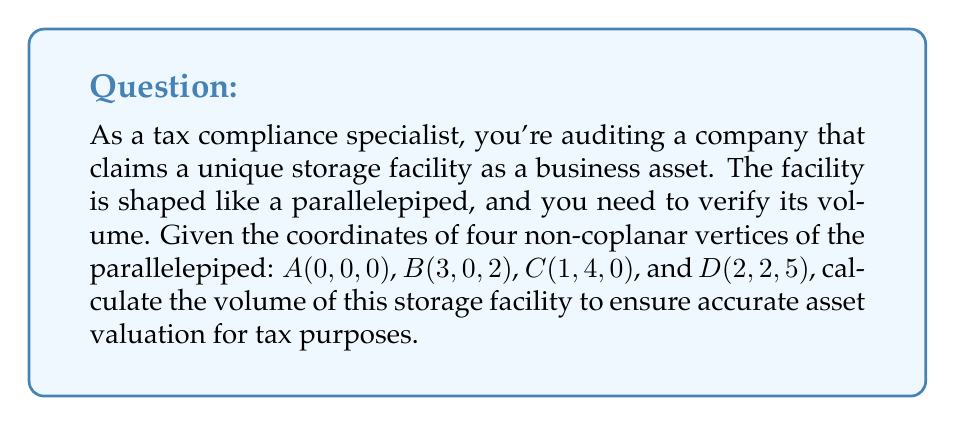Give your solution to this math problem. Let's approach this step-by-step:

1) The volume of a parallelepiped can be calculated using the scalar triple product of three vectors representing its edges:

   $V = |\vec{a} \cdot (\vec{b} \times \vec{c})|$

   where $\vec{a}$, $\vec{b}$, and $\vec{c}$ are vectors representing three edges meeting at a vertex.

2) We can choose vertex $A$ as our starting point and create vectors $\vec{AB}$, $\vec{AC}$, and $\vec{AD}$:

   $\vec{AB} = B - A = (3,0,2) - (0,0,0) = (3,0,2)$
   $\vec{AC} = C - A = (1,4,0) - (0,0,0) = (1,4,0)$
   $\vec{AD} = D - A = (2,2,5) - (0,0,0) = (2,2,5)$

3) Now, we need to calculate $\vec{AC} \times \vec{AD}$:

   $\vec{AC} \times \vec{AD} = \begin{vmatrix} 
   \hat{i} & \hat{j} & \hat{k} \\
   1 & 4 & 0 \\
   2 & 2 & 5
   \end{vmatrix} = (20)\hat{i} + (-5)\hat{j} + (-6)\hat{k} = (20,-5,-6)$

4) Next, we calculate the dot product of $\vec{AB}$ with this result:

   $\vec{AB} \cdot (\vec{AC} \times \vec{AD}) = (3,0,2) \cdot (20,-5,-6)$
                                              $= 3(20) + 0(-5) + 2(-6)$
                                              $= 60 - 12 = 48$

5) The absolute value of this result is the volume of the parallelepiped:

   $V = |48| = 48$

Therefore, the volume of the storage facility is 48 cubic units.
Answer: 48 cubic units 